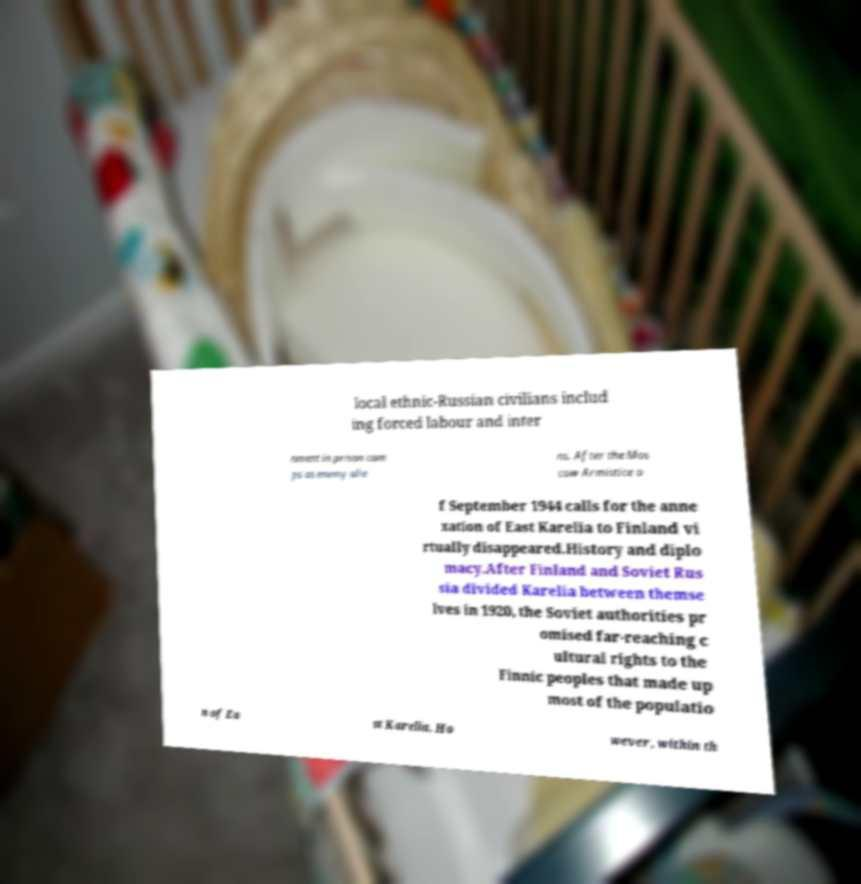Please identify and transcribe the text found in this image. local ethnic-Russian civilians includ ing forced labour and inter nment in prison cam ps as enemy alie ns. After the Mos cow Armistice o f September 1944 calls for the anne xation of East Karelia to Finland vi rtually disappeared.History and diplo macy.After Finland and Soviet Rus sia divided Karelia between themse lves in 1920, the Soviet authorities pr omised far-reaching c ultural rights to the Finnic peoples that made up most of the populatio n of Ea st Karelia. Ho wever, within th 